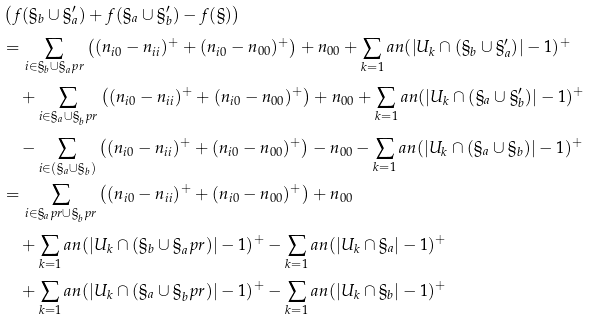Convert formula to latex. <formula><loc_0><loc_0><loc_500><loc_500>& \left ( f ( \S _ { b } \cup \S _ { a } ^ { \prime } ) + f ( \S _ { a } \cup \S _ { b } ^ { \prime } ) - f ( \S ) \right ) \\ & = \sum _ { i \in \S _ { b } \cup \S _ { a } ^ { \ } p r } \left ( ( n _ { i 0 } - n _ { i i } ) ^ { + } + ( n _ { i 0 } - n _ { 0 0 } ) ^ { + } \right ) + n _ { 0 0 } + \sum _ { k = 1 } ^ { \ } a n ( | U _ { k } \cap ( \S _ { b } \cup \S _ { a } ^ { \prime } ) | - 1 ) ^ { + } \\ & \quad + \sum _ { i \in \S _ { a } \cup \S _ { b } ^ { \ } p r } \left ( ( n _ { i 0 } - n _ { i i } ) ^ { + } + ( n _ { i 0 } - n _ { 0 0 } ) ^ { + } \right ) + n _ { 0 0 } + \sum _ { k = 1 } ^ { \ } a n ( | U _ { k } \cap ( \S _ { a } \cup \S _ { b } ^ { \prime } ) | - 1 ) ^ { + } \\ & \quad - \sum _ { i \in ( \S _ { a } \cup \S _ { b } ) } \left ( ( n _ { i 0 } - n _ { i i } ) ^ { + } + ( n _ { i 0 } - n _ { 0 0 } ) ^ { + } \right ) - n _ { 0 0 } - \sum _ { k = 1 } ^ { \ } a n ( | U _ { k } \cap ( \S _ { a } \cup \S _ { b } ) | - 1 ) ^ { + } \\ & = \sum _ { i \in \S _ { a } ^ { \ } p r \cup \S _ { b } ^ { \ } p r } \left ( ( n _ { i 0 } - n _ { i i } ) ^ { + } + ( n _ { i 0 } - n _ { 0 0 } ) ^ { + } \right ) + n _ { 0 0 } \\ & \quad + \sum _ { k = 1 } ^ { \ } a n ( | U _ { k } \cap ( \S _ { b } \cup \S _ { a } ^ { \ } p r ) | - 1 ) ^ { + } - \sum _ { k = 1 } ^ { \ } a n ( | U _ { k } \cap \S _ { a } | - 1 ) ^ { + } \\ & \quad + \sum _ { k = 1 } ^ { \ } a n ( | U _ { k } \cap ( \S _ { a } \cup \S _ { b } ^ { \ } p r ) | - 1 ) ^ { + } - \sum _ { k = 1 } ^ { \ } a n ( | U _ { k } \cap \S _ { b } | - 1 ) ^ { + }</formula> 